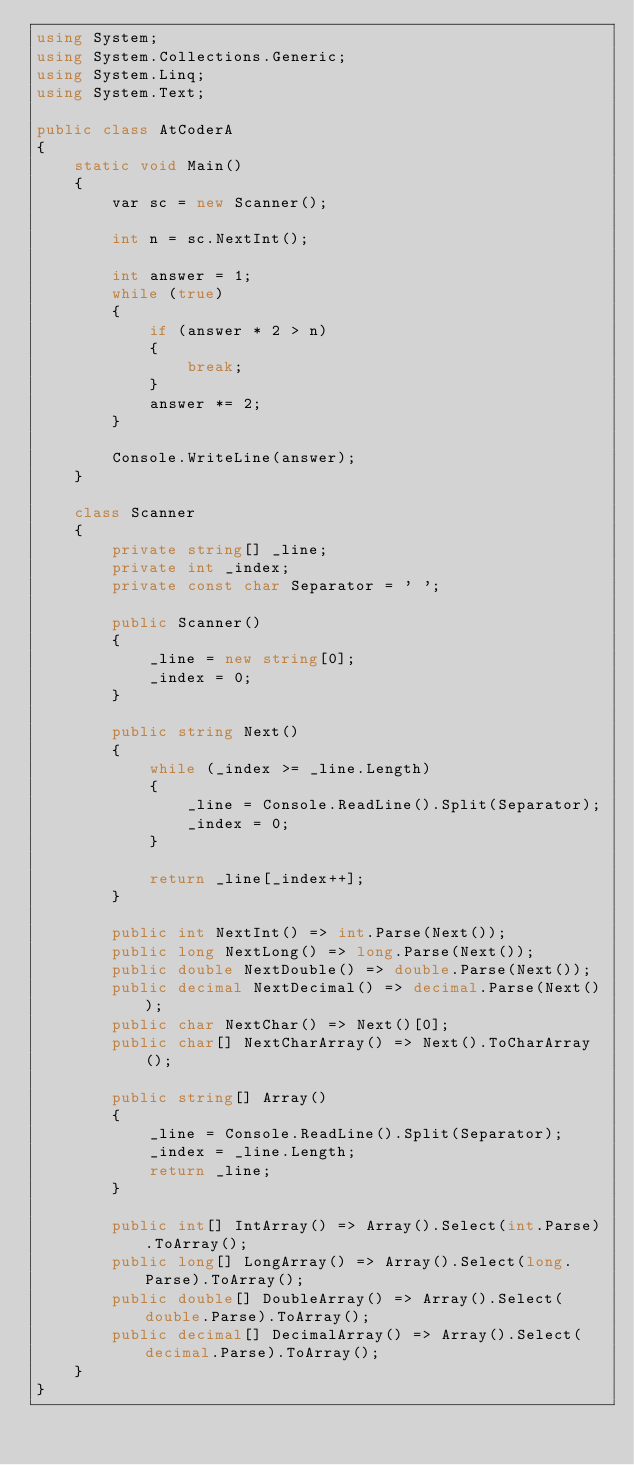<code> <loc_0><loc_0><loc_500><loc_500><_C#_>using System;
using System.Collections.Generic;
using System.Linq;
using System.Text;

public class AtCoderA
{
    static void Main()
    {
        var sc = new Scanner();

        int n = sc.NextInt();

        int answer = 1;
        while (true)
        {
            if (answer * 2 > n)
            {
                break;
            }
            answer *= 2;
        }

        Console.WriteLine(answer);
    }

    class Scanner
    {
        private string[] _line;
        private int _index;
        private const char Separator = ' ';

        public Scanner()
        {
            _line = new string[0];
            _index = 0;
        }

        public string Next()
        {
            while (_index >= _line.Length)
            {
                _line = Console.ReadLine().Split(Separator);
                _index = 0;
            }

            return _line[_index++];
        }

        public int NextInt() => int.Parse(Next());
        public long NextLong() => long.Parse(Next());
        public double NextDouble() => double.Parse(Next());
        public decimal NextDecimal() => decimal.Parse(Next());
        public char NextChar() => Next()[0];
        public char[] NextCharArray() => Next().ToCharArray();

        public string[] Array()
        {
            _line = Console.ReadLine().Split(Separator);
            _index = _line.Length;
            return _line;
        }

        public int[] IntArray() => Array().Select(int.Parse).ToArray();
        public long[] LongArray() => Array().Select(long.Parse).ToArray();
        public double[] DoubleArray() => Array().Select(double.Parse).ToArray();
        public decimal[] DecimalArray() => Array().Select(decimal.Parse).ToArray();
    }
}</code> 